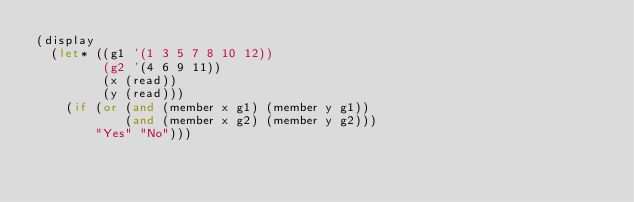Convert code to text. <code><loc_0><loc_0><loc_500><loc_500><_Scheme_>(display
  (let* ((g1 '(1 3 5 7 8 10 12))
         (g2 '(4 6 9 11))
         (x (read))
         (y (read)))
    (if (or (and (member x g1) (member y g1))
            (and (member x g2) (member y g2)))
        "Yes" "No")))
</code> 